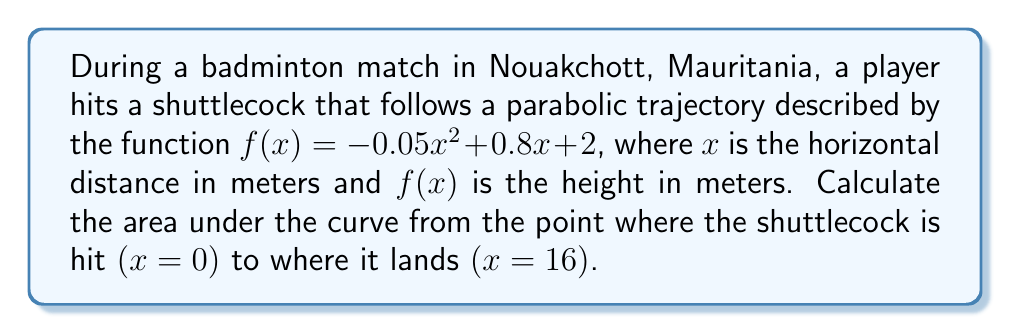Give your solution to this math problem. To find the area under the curve, we need to integrate the function $f(x)$ from $x=0$ to $x=16$. 

Step 1: Set up the definite integral
$$\int_0^{16} (-0.05x^2 + 0.8x + 2) \, dx$$

Step 2: Integrate the function
$$\int (-0.05x^2 + 0.8x + 2) \, dx = -\frac{0.05}{3}x^3 + 0.4x^2 + 2x + C$$

Step 3: Apply the limits of integration
$$\left[-\frac{0.05}{3}x^3 + 0.4x^2 + 2x\right]_0^{16}$$

Step 4: Evaluate at $x=16$ and $x=0$
$$\left(-\frac{0.05}{3}(16)^3 + 0.4(16)^2 + 2(16)\right) - \left(-\frac{0.05}{3}(0)^3 + 0.4(0)^2 + 2(0)\right)$$

Step 5: Simplify
$$(-85.33 + 102.4 + 32) - (0) = 49.07$$

Therefore, the area under the curve is 49.07 square meters.
Answer: 49.07 m² 